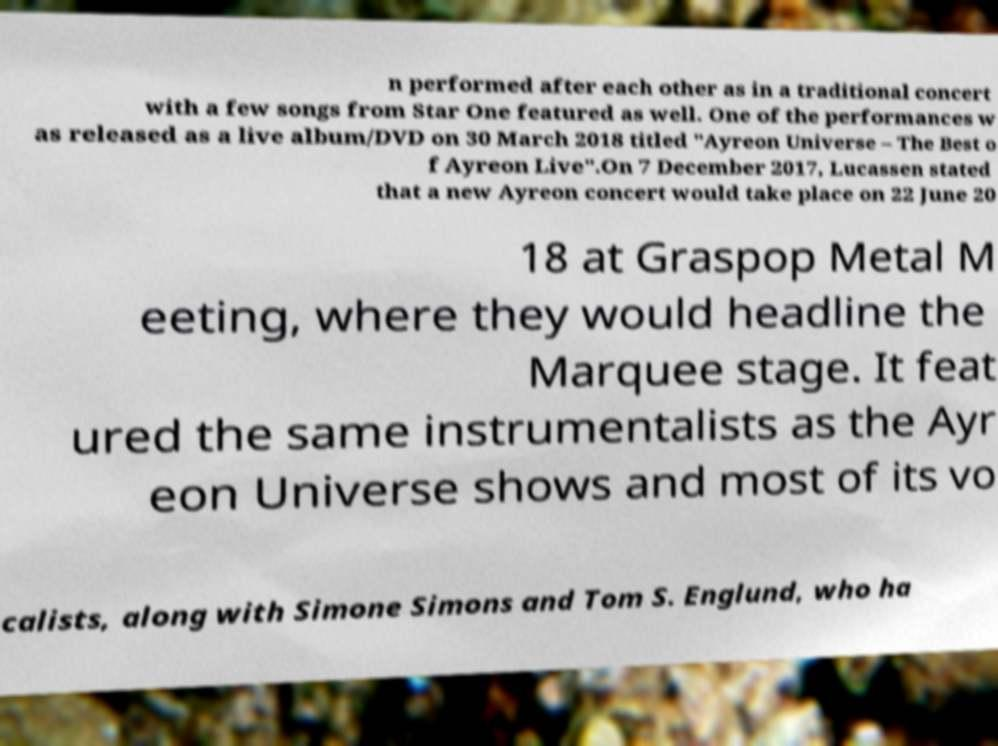Please read and relay the text visible in this image. What does it say? n performed after each other as in a traditional concert with a few songs from Star One featured as well. One of the performances w as released as a live album/DVD on 30 March 2018 titled "Ayreon Universe – The Best o f Ayreon Live".On 7 December 2017, Lucassen stated that a new Ayreon concert would take place on 22 June 20 18 at Graspop Metal M eeting, where they would headline the Marquee stage. It feat ured the same instrumentalists as the Ayr eon Universe shows and most of its vo calists, along with Simone Simons and Tom S. Englund, who ha 